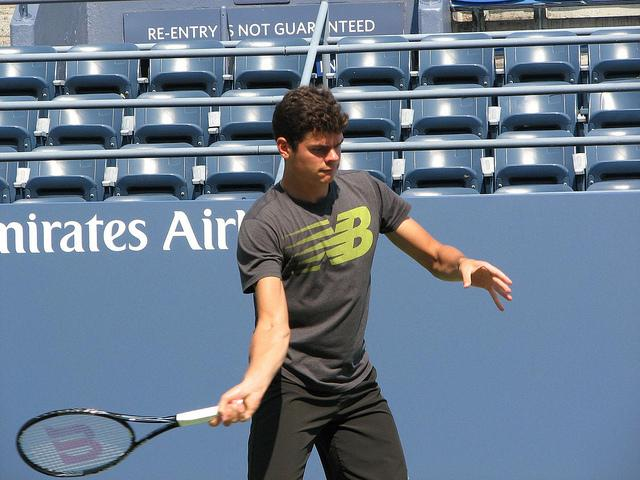What city is the sponsor of the arena located? dubai 